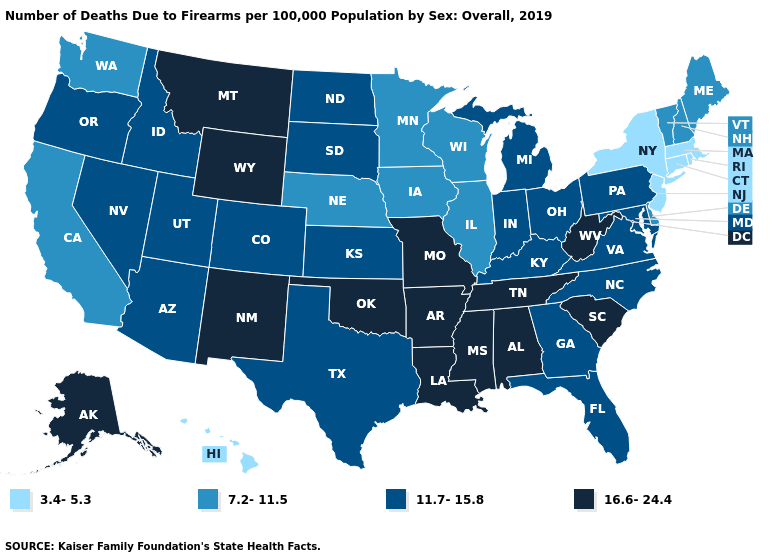Name the states that have a value in the range 11.7-15.8?
Short answer required. Arizona, Colorado, Florida, Georgia, Idaho, Indiana, Kansas, Kentucky, Maryland, Michigan, Nevada, North Carolina, North Dakota, Ohio, Oregon, Pennsylvania, South Dakota, Texas, Utah, Virginia. Name the states that have a value in the range 11.7-15.8?
Give a very brief answer. Arizona, Colorado, Florida, Georgia, Idaho, Indiana, Kansas, Kentucky, Maryland, Michigan, Nevada, North Carolina, North Dakota, Ohio, Oregon, Pennsylvania, South Dakota, Texas, Utah, Virginia. What is the value of Idaho?
Write a very short answer. 11.7-15.8. What is the value of Kentucky?
Keep it brief. 11.7-15.8. Does Michigan have the lowest value in the MidWest?
Answer briefly. No. Does Wyoming have the highest value in the West?
Give a very brief answer. Yes. Does the first symbol in the legend represent the smallest category?
Short answer required. Yes. What is the highest value in the Northeast ?
Write a very short answer. 11.7-15.8. How many symbols are there in the legend?
Quick response, please. 4. Among the states that border Arizona , which have the highest value?
Give a very brief answer. New Mexico. Among the states that border Ohio , does West Virginia have the lowest value?
Quick response, please. No. Name the states that have a value in the range 7.2-11.5?
Write a very short answer. California, Delaware, Illinois, Iowa, Maine, Minnesota, Nebraska, New Hampshire, Vermont, Washington, Wisconsin. Does the first symbol in the legend represent the smallest category?
Answer briefly. Yes. What is the value of Pennsylvania?
Quick response, please. 11.7-15.8. Name the states that have a value in the range 11.7-15.8?
Give a very brief answer. Arizona, Colorado, Florida, Georgia, Idaho, Indiana, Kansas, Kentucky, Maryland, Michigan, Nevada, North Carolina, North Dakota, Ohio, Oregon, Pennsylvania, South Dakota, Texas, Utah, Virginia. 